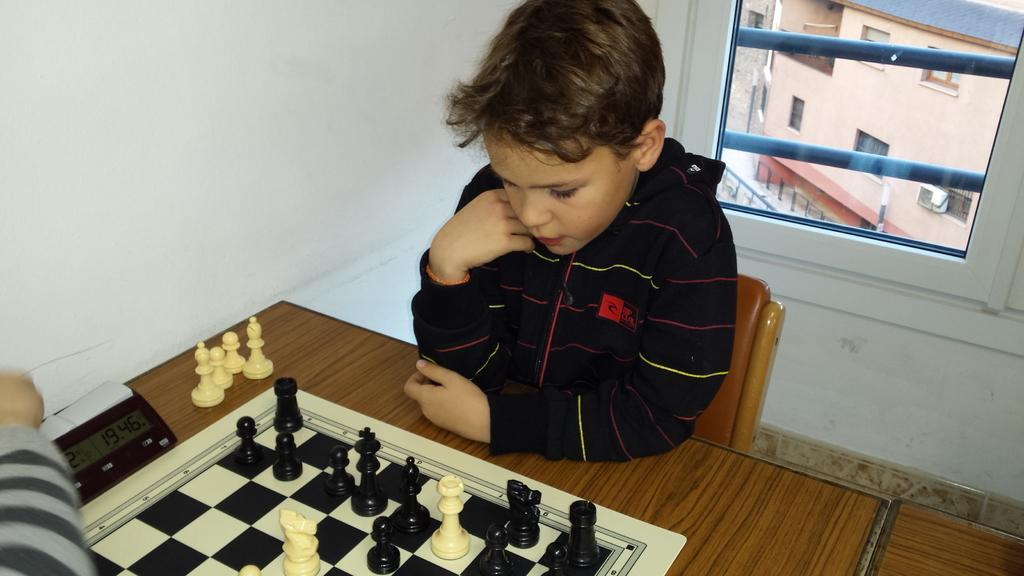Please provide a concise description of this image. On the background we can see a wall and through window glass we can see a building and outside view. Here we can see a boy sitting on a chair in front of a table and on the table we can see chess pieces and chess boards. This is a digital clock. 